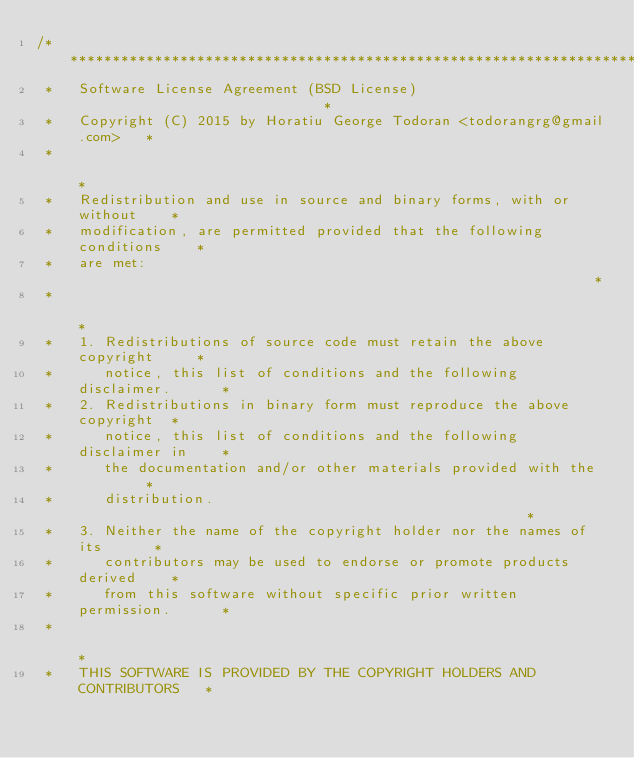Convert code to text. <code><loc_0><loc_0><loc_500><loc_500><_C++_>/***************************************************************************
 *   Software License Agreement (BSD License)                              *
 *   Copyright (C) 2015 by Horatiu George Todoran <todorangrg@gmail.com>   *
 *                                                                         *
 *   Redistribution and use in source and binary forms, with or without    *
 *   modification, are permitted provided that the following conditions    *
 *   are met:                                                              *
 *                                                                         *
 *   1. Redistributions of source code must retain the above copyright     *
 *      notice, this list of conditions and the following disclaimer.      *
 *   2. Redistributions in binary form must reproduce the above copyright  *
 *      notice, this list of conditions and the following disclaimer in    *
 *      the documentation and/or other materials provided with the         *
 *      distribution.                                                      *
 *   3. Neither the name of the copyright holder nor the names of its      *
 *      contributors may be used to endorse or promote products derived    *
 *      from this software without specific prior written permission.      *
 *                                                                         *
 *   THIS SOFTWARE IS PROVIDED BY THE COPYRIGHT HOLDERS AND CONTRIBUTORS   *</code> 